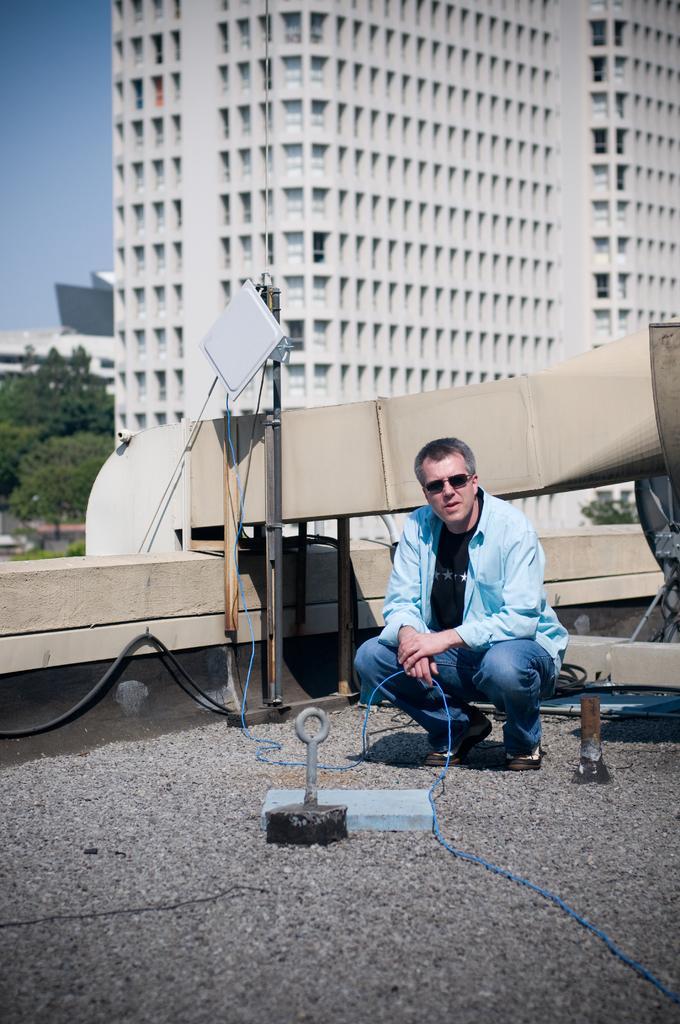Describe this image in one or two sentences. In this image, we can see a person holding some object. We can see the ground with some objects. We can also see some buildings, trees. We can also see the sky. 